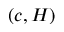Convert formula to latex. <formula><loc_0><loc_0><loc_500><loc_500>( c , H )</formula> 